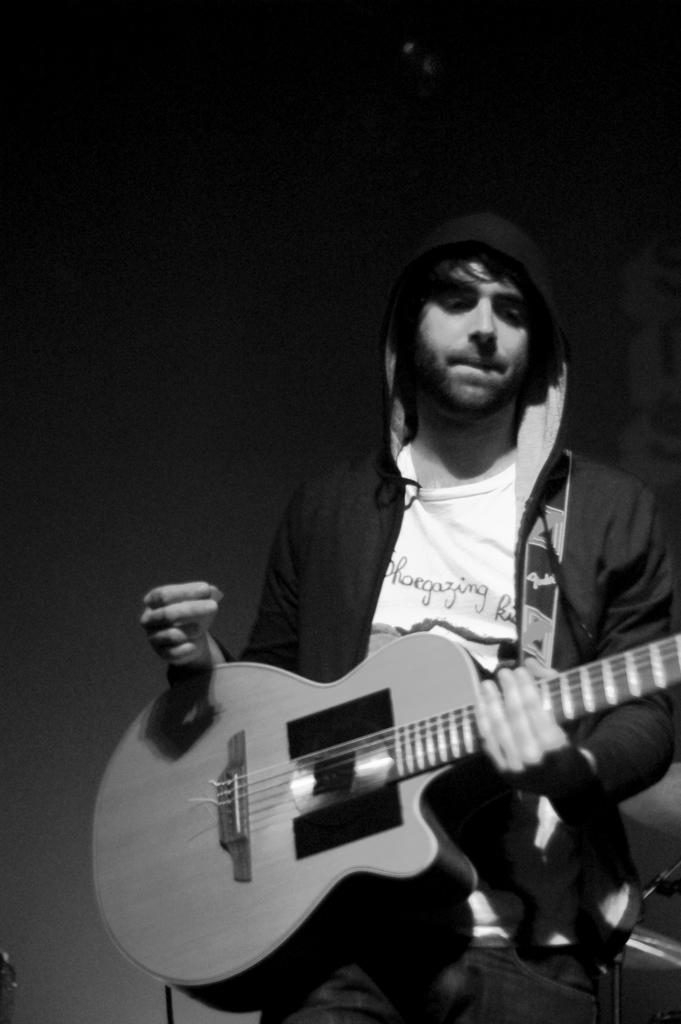What is the main subject of the image? The main subject of the image is a guy. What is the guy wearing in the image? The guy is wearing a jacket in the image. What activity is the guy engaged in? The guy is playing a guitar in the image. What type of thunder can be heard in the background of the image? There is no sound or indication of thunder in the image; it only shows a guy playing a guitar. 